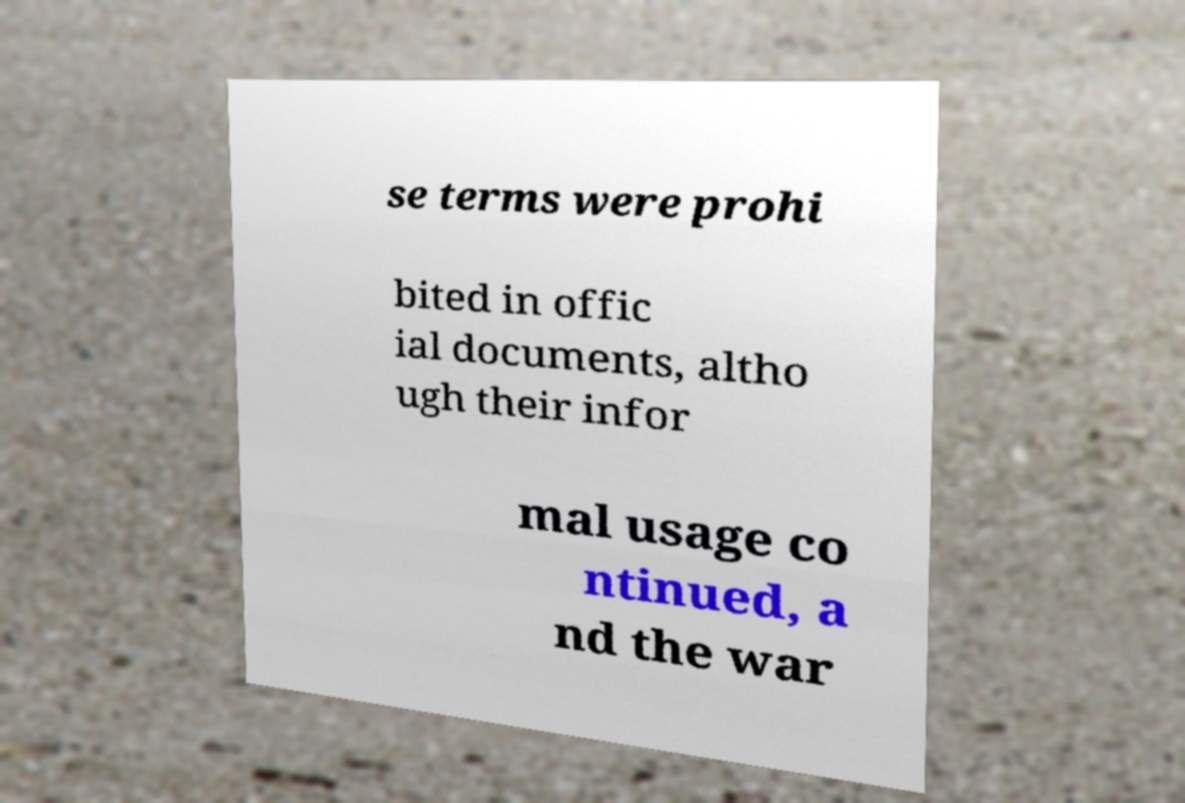Can you accurately transcribe the text from the provided image for me? se terms were prohi bited in offic ial documents, altho ugh their infor mal usage co ntinued, a nd the war 